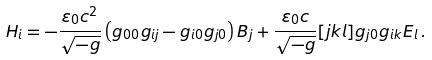<formula> <loc_0><loc_0><loc_500><loc_500>H _ { i } = - \frac { \varepsilon _ { 0 } c ^ { 2 } } { \sqrt { - g } } \left ( g _ { 0 0 } g _ { i j } - g _ { i 0 } g _ { j 0 } \right ) B _ { j } + \frac { \varepsilon _ { 0 } c } { \sqrt { - g } } [ j k l ] g _ { j 0 } g _ { i k } E _ { l } \, .</formula> 